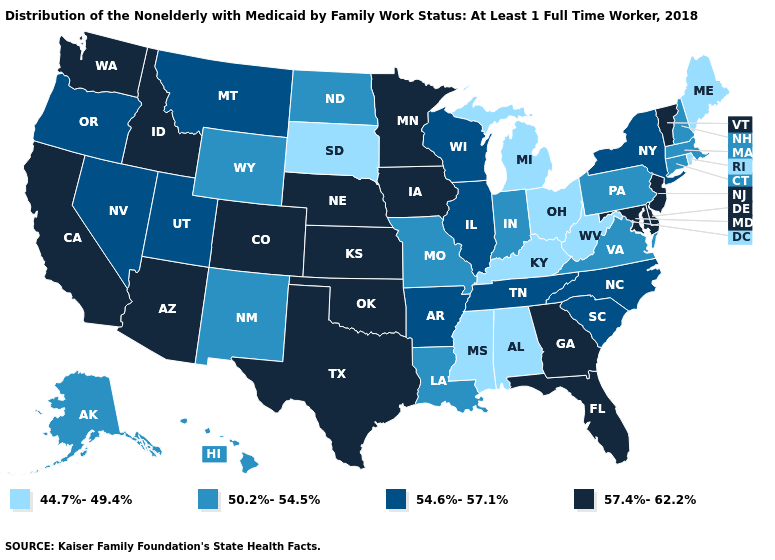Name the states that have a value in the range 57.4%-62.2%?
Keep it brief. Arizona, California, Colorado, Delaware, Florida, Georgia, Idaho, Iowa, Kansas, Maryland, Minnesota, Nebraska, New Jersey, Oklahoma, Texas, Vermont, Washington. What is the value of Colorado?
Answer briefly. 57.4%-62.2%. Name the states that have a value in the range 57.4%-62.2%?
Be succinct. Arizona, California, Colorado, Delaware, Florida, Georgia, Idaho, Iowa, Kansas, Maryland, Minnesota, Nebraska, New Jersey, Oklahoma, Texas, Vermont, Washington. Does the map have missing data?
Give a very brief answer. No. Does Missouri have the same value as North Carolina?
Answer briefly. No. Does Oregon have a higher value than Missouri?
Write a very short answer. Yes. What is the lowest value in the South?
Concise answer only. 44.7%-49.4%. Which states have the lowest value in the South?
Be succinct. Alabama, Kentucky, Mississippi, West Virginia. What is the highest value in states that border New York?
Give a very brief answer. 57.4%-62.2%. What is the value of California?
Answer briefly. 57.4%-62.2%. Name the states that have a value in the range 50.2%-54.5%?
Short answer required. Alaska, Connecticut, Hawaii, Indiana, Louisiana, Massachusetts, Missouri, New Hampshire, New Mexico, North Dakota, Pennsylvania, Virginia, Wyoming. Is the legend a continuous bar?
Be succinct. No. Name the states that have a value in the range 57.4%-62.2%?
Write a very short answer. Arizona, California, Colorado, Delaware, Florida, Georgia, Idaho, Iowa, Kansas, Maryland, Minnesota, Nebraska, New Jersey, Oklahoma, Texas, Vermont, Washington. What is the highest value in states that border Vermont?
Give a very brief answer. 54.6%-57.1%. Which states have the highest value in the USA?
Give a very brief answer. Arizona, California, Colorado, Delaware, Florida, Georgia, Idaho, Iowa, Kansas, Maryland, Minnesota, Nebraska, New Jersey, Oklahoma, Texas, Vermont, Washington. 